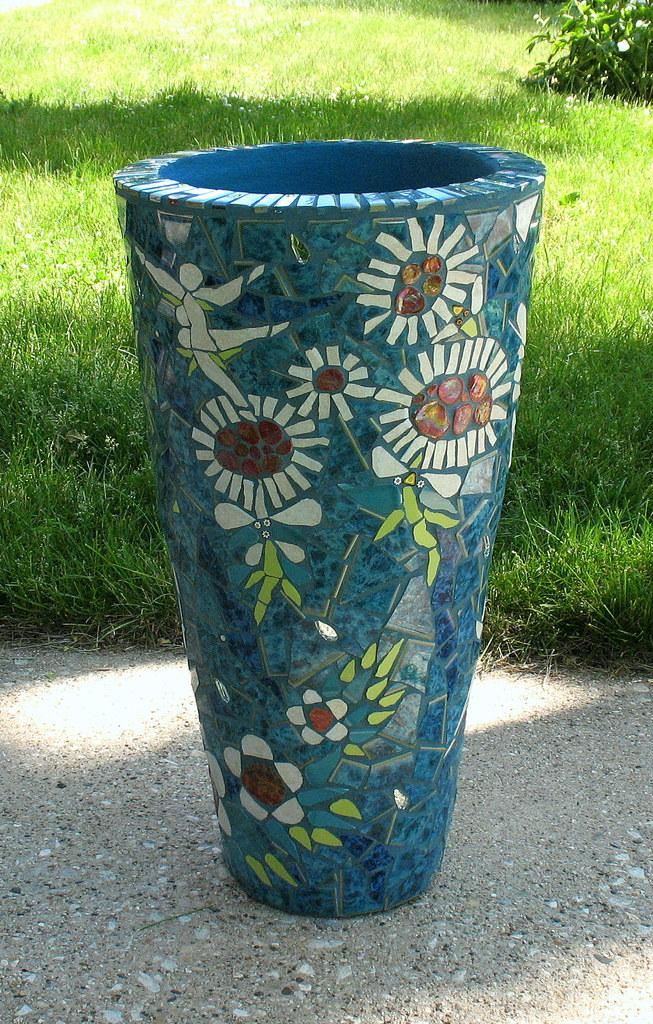What object can be seen in the image that is typically used for holding flowers? There is a vase in the image that is typically used for holding flowers. What type of vegetation is visible at the bottom of the image? Grass is present at the bottom of the image. Where is the plant located in the image? There is a plant on the right side of the image. What type of shoe can be seen in the image? There is no shoe present in the image. How many flowers are visible in the image? The image does not show any flowers; it only features a vase and a plant. 